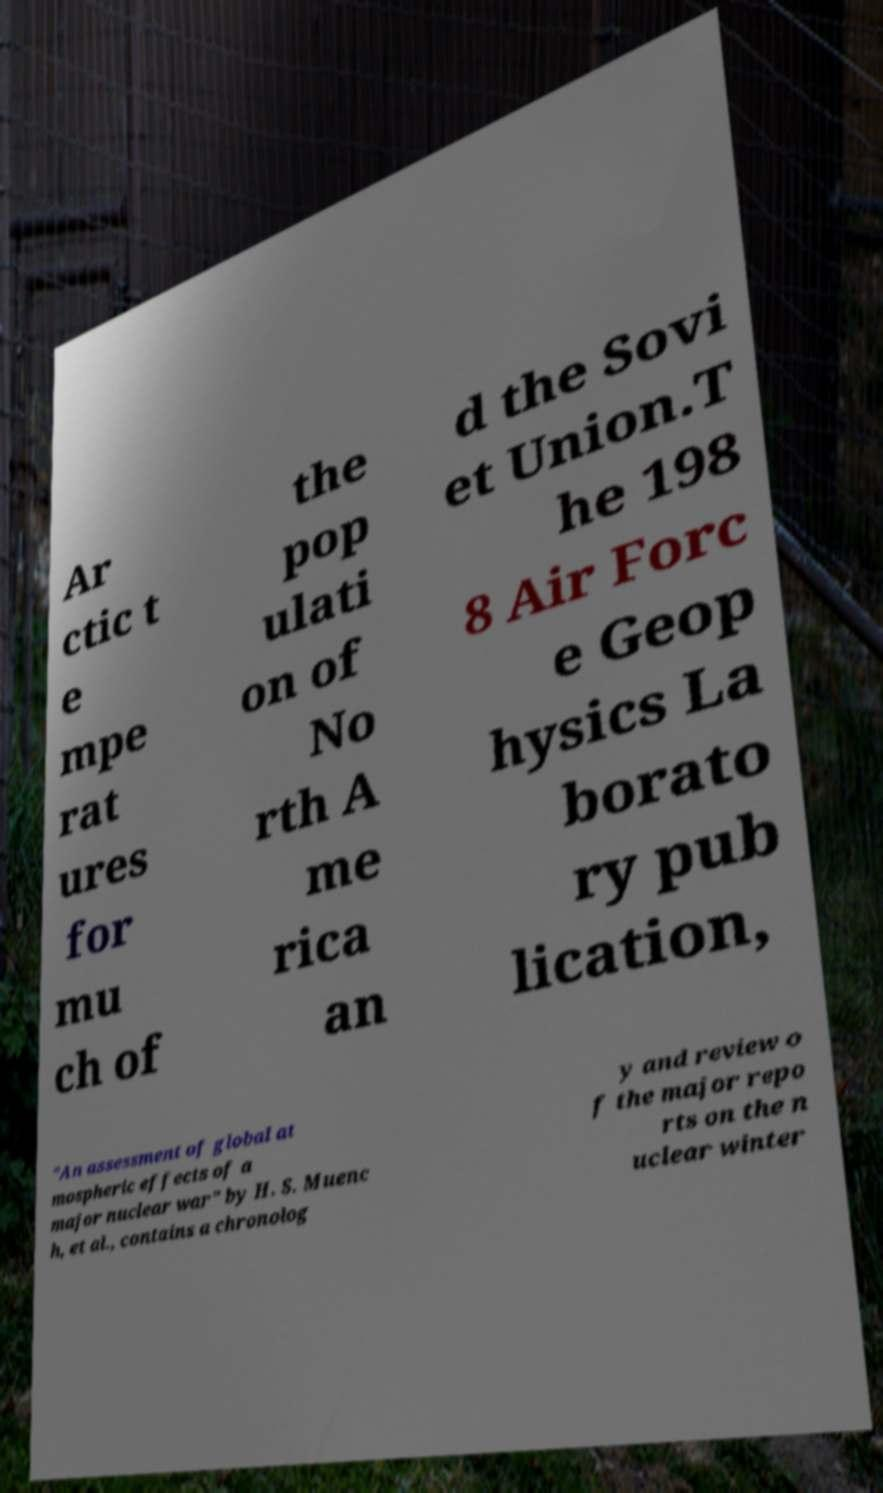Please read and relay the text visible in this image. What does it say? Ar ctic t e mpe rat ures for mu ch of the pop ulati on of No rth A me rica an d the Sovi et Union.T he 198 8 Air Forc e Geop hysics La borato ry pub lication, "An assessment of global at mospheric effects of a major nuclear war" by H. S. Muenc h, et al., contains a chronolog y and review o f the major repo rts on the n uclear winter 